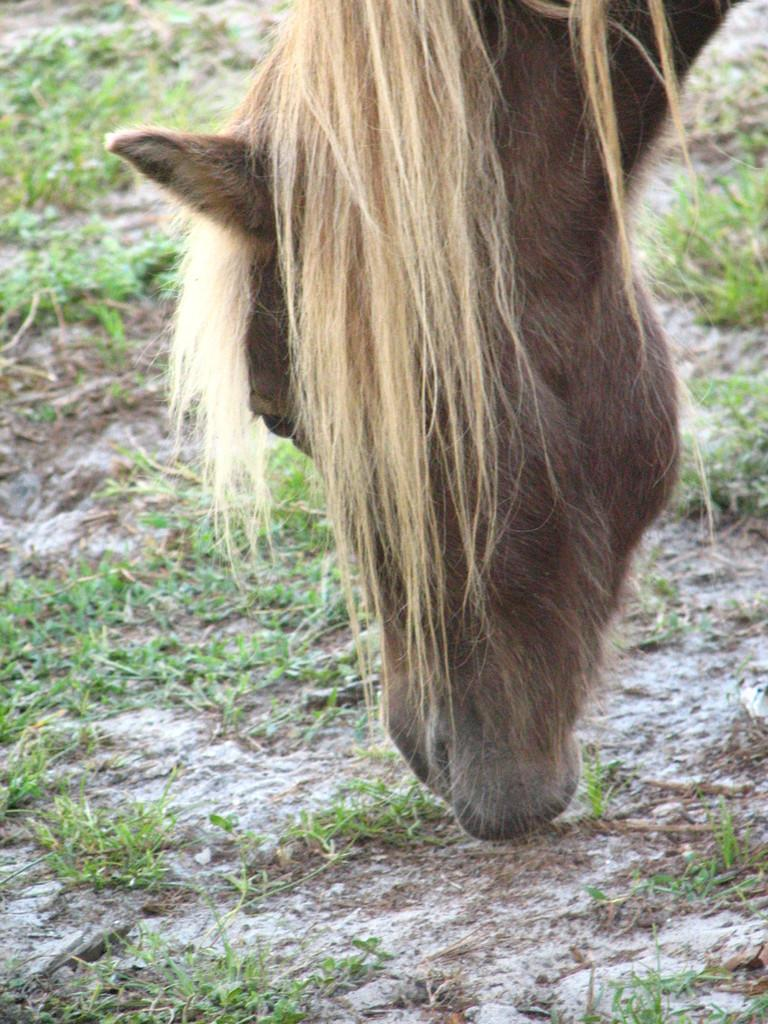What is the main subject in the foreground of the image? There is a horse in the foreground of the image. Can you describe the condition of the horse? The horse is truncated, possibly a statue or a part of the image is not visible. What is the horse doing in the image? The horse is eating grass. What type of vegetation can be seen in the background of the image? There is grass in the background of the image. What can be seen in the distance in the image? The land is visible in the background. Can you hear the horse cry in the image? There is no sound in the image, so it is not possible to hear the horse cry. What type of goat is present in the image? There is no goat present in the image; it features a horse. 